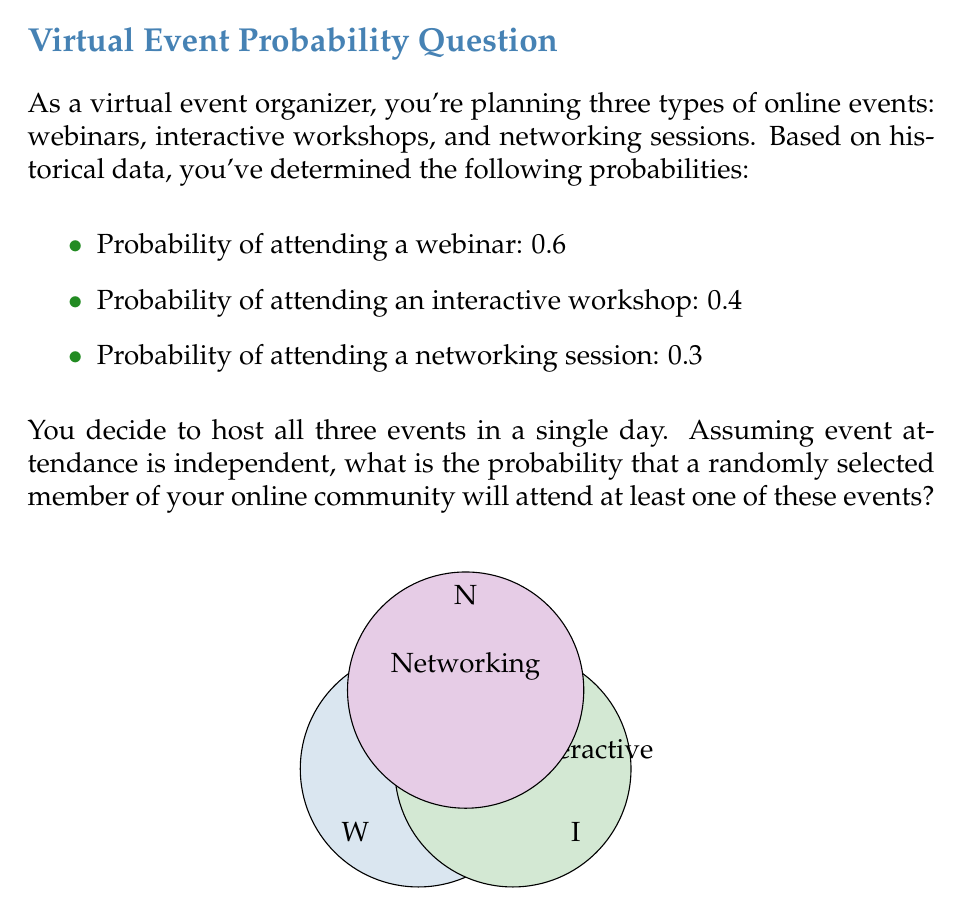Solve this math problem. Let's approach this step-by-step using probability theory:

1) First, let's define our events:
   W: Attending a webinar
   I: Attending an interactive workshop
   N: Attending a networking session

2) We're looking for the probability of attending at least one event. It's easier to calculate the probability of not attending any event and then subtract from 1.

3) Probability of not attending each event:
   P(not W) = 1 - 0.6 = 0.4
   P(not I) = 1 - 0.4 = 0.6
   P(not N) = 1 - 0.3 = 0.7

4) Since the events are independent, the probability of not attending any event is the product of these probabilities:

   P(not W and not I and not N) = P(not W) × P(not I) × P(not N)
                                 = 0.4 × 0.6 × 0.7
                                 = 0.168

5) Therefore, the probability of attending at least one event is:

   P(at least one) = 1 - P(none)
                   = 1 - 0.168
                   = 0.832

6) We can also express this using the complement rule and the multiplication rule of probability:

   $$P(\text{at least one}) = 1 - [(1-0.6) \times (1-0.4) \times (1-0.3)]$$
                            $$= 1 - [0.4 \times 0.6 \times 0.7]$$
                            $$= 1 - 0.168$$
                            $$= 0.832$$

Thus, there is an 83.2% chance that a randomly selected member will attend at least one of the events.
Answer: 0.832 or 83.2% 